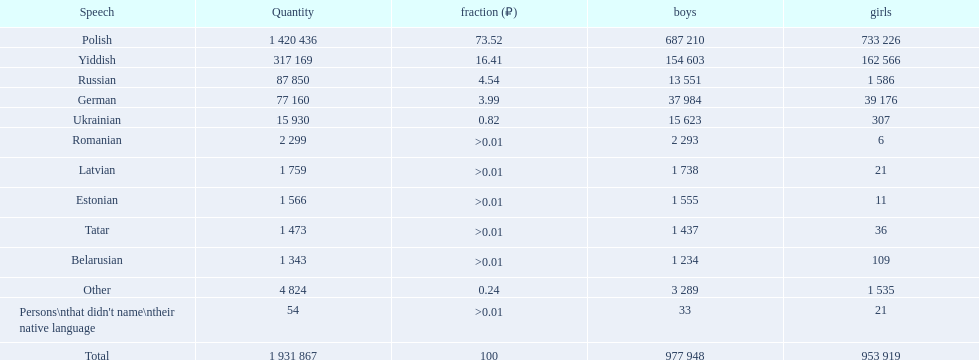What are the languages of the warsaw governorate? Polish, Yiddish, Russian, German, Ukrainian, Romanian, Latvian, Estonian, Tatar, Belarusian, Other. What is the percentage of polish? 73.52. What is the next highest amount? 16.41. Help me parse the entirety of this table. {'header': ['Speech', 'Quantity', 'fraction (₽)', 'boys', 'girls'], 'rows': [['Polish', '1 420 436', '73.52', '687 210', '733 226'], ['Yiddish', '317 169', '16.41', '154 603', '162 566'], ['Russian', '87 850', '4.54', '13 551', '1 586'], ['German', '77 160', '3.99', '37 984', '39 176'], ['Ukrainian', '15 930', '0.82', '15 623', '307'], ['Romanian', '2 299', '>0.01', '2 293', '6'], ['Latvian', '1 759', '>0.01', '1 738', '21'], ['Estonian', '1 566', '>0.01', '1 555', '11'], ['Tatar', '1 473', '>0.01', '1 437', '36'], ['Belarusian', '1 343', '>0.01', '1 234', '109'], ['Other', '4 824', '0.24', '3 289', '1 535'], ["Persons\\nthat didn't name\\ntheir native language", '54', '>0.01', '33', '21'], ['Total', '1 931 867', '100', '977 948', '953 919']]} What is the language with this amount? Yiddish. 